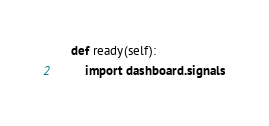<code> <loc_0><loc_0><loc_500><loc_500><_Python_>
    def ready(self):
        import dashboard.signals
</code> 